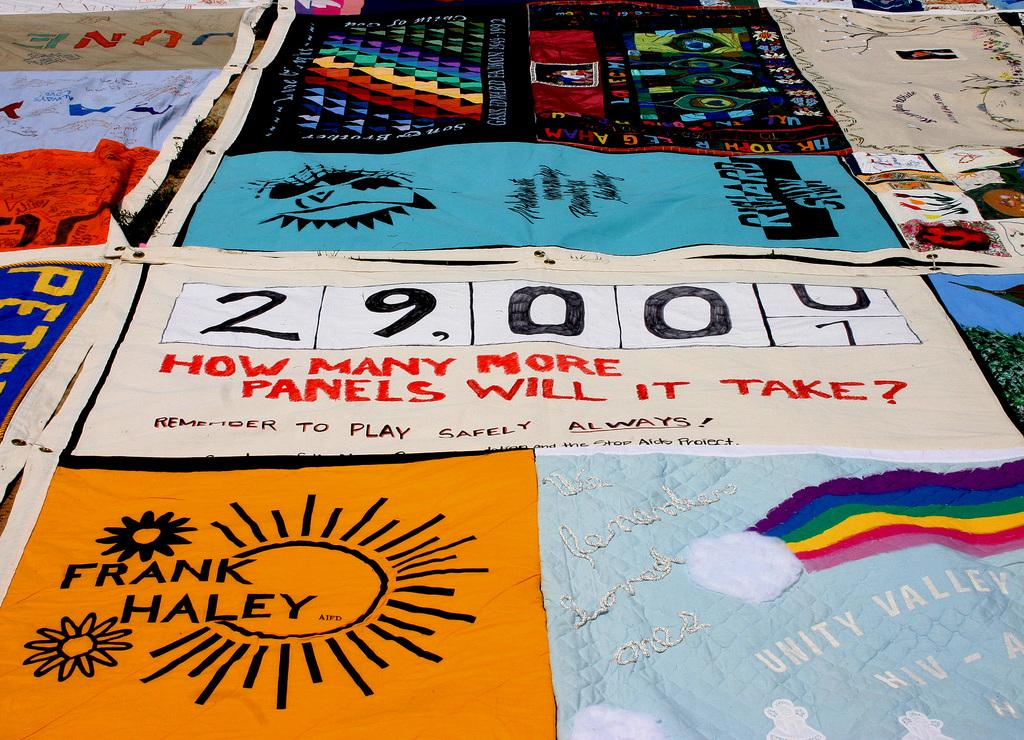What is located in the foreground of the image? There are banners in the foreground of the image. Where is the faucet located in the image? There is no faucet present in the image. What type of joke can be seen on the banners in the image? There is no joke present on the banners in the image. 